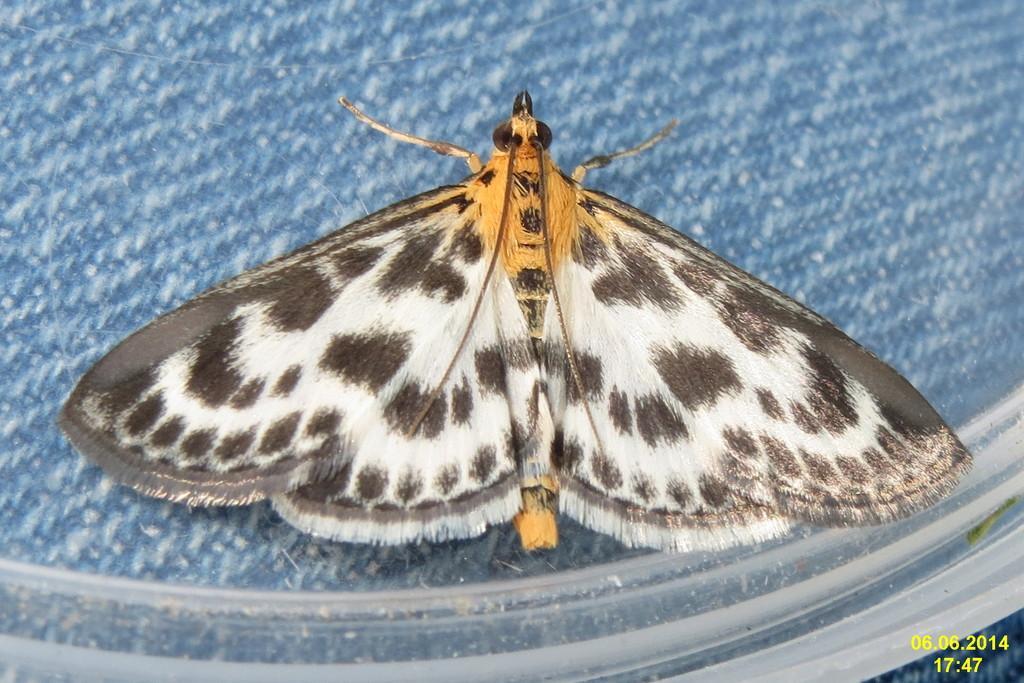How would you summarize this image in a sentence or two? In this picture I can see a butterfly in the middle, there are numbers in the the bottom right hand side. 